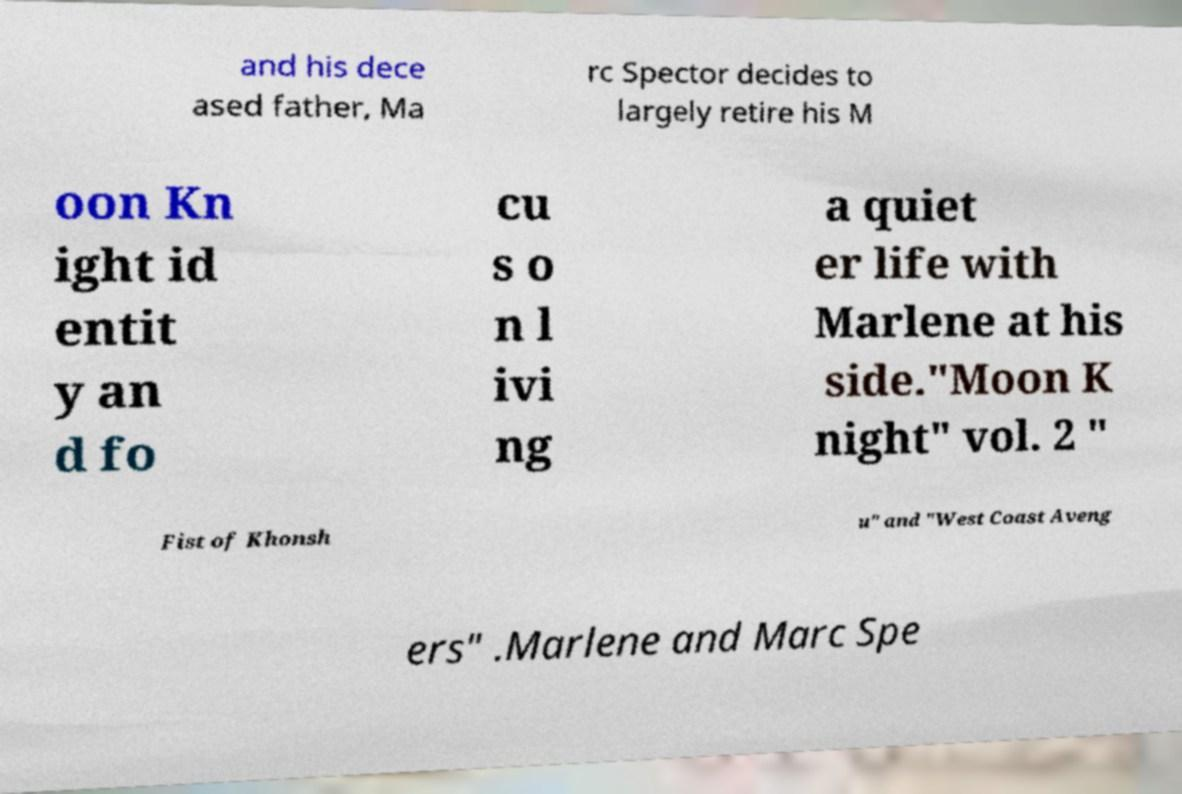Can you accurately transcribe the text from the provided image for me? and his dece ased father, Ma rc Spector decides to largely retire his M oon Kn ight id entit y an d fo cu s o n l ivi ng a quiet er life with Marlene at his side."Moon K night" vol. 2 " Fist of Khonsh u" and "West Coast Aveng ers" .Marlene and Marc Spe 